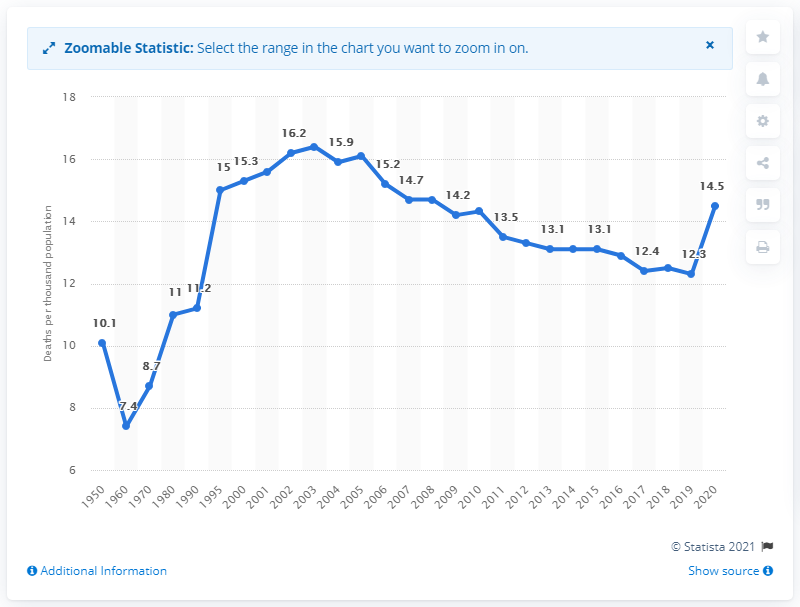Draw attention to some important aspects in this diagram. In 2003, the highest rate of deaths per thousand inhabitants in Russia was 16.4. The mortality rate in Russia in 2020 was 14.5%. 